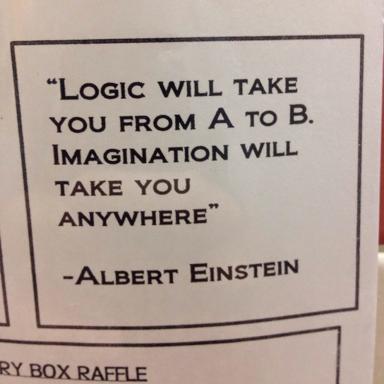Can you explore how the theme of the quote might apply to personal growth and career development? The quote illuminates a profound truth applicable to personal and career growth. Imagination allows individuals to envision their ideal careers and achievements beyond the conventional pathways defined by logic. It encourages risk-taking, innovation, and the pursuit of passions that might not initially seem logical but can lead to fulfilling and groundbreaking careers. 